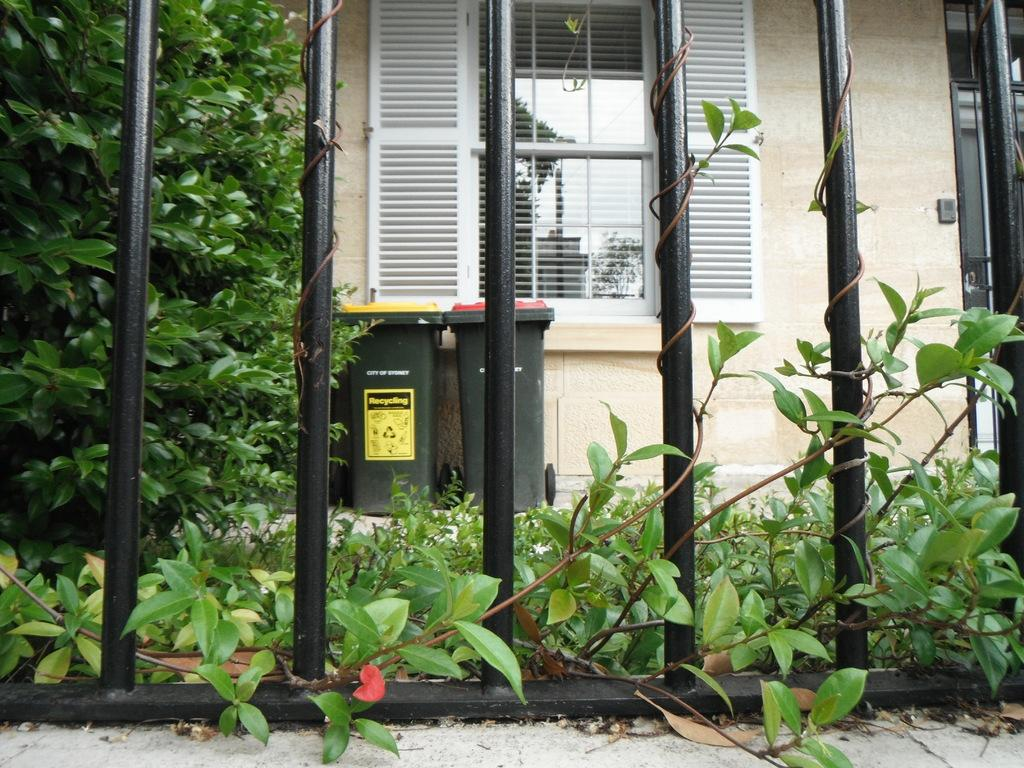What type of containers are present in the image? There are dustbins in the image. What type of natural elements can be seen in the image? There are trees and plants in the image. What part of the environment is visible in the image? The ground is visible in the image. What type of man-made structure is present in the image? There is a building in the image. What architectural feature is visible in the image? There is a window in the image. What caption is written on the dustbins in the image? There is no caption visible on the dustbins in the image. What type of face can be seen on the trees in the image? There are no faces present on the trees in the image. 